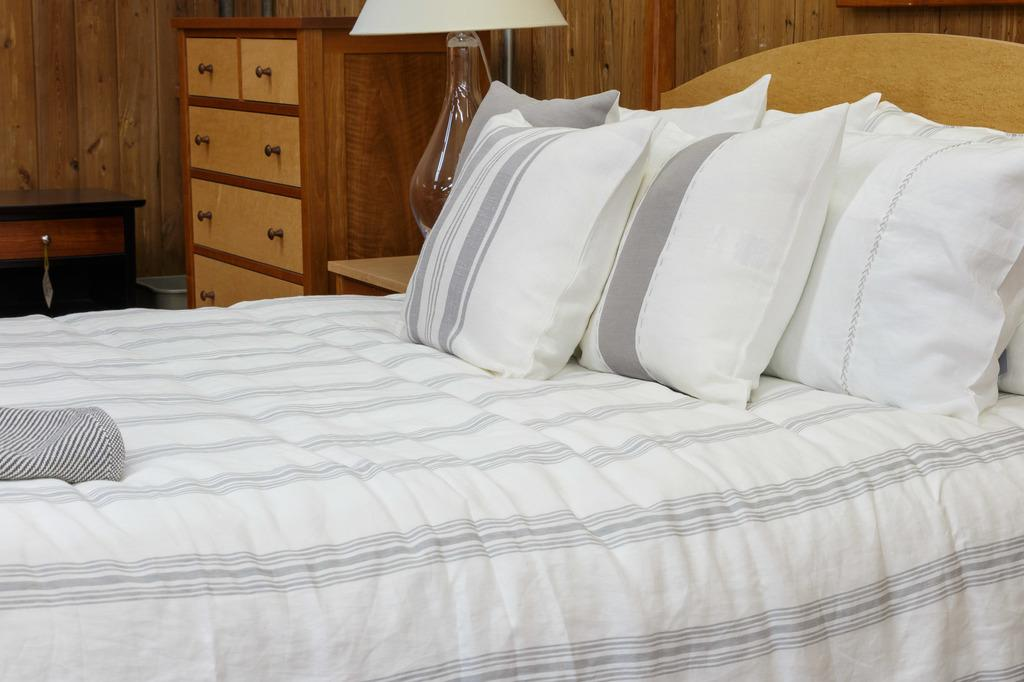What piece of furniture is the main subject in the image? There is a bed in the image. What is placed on the bed? There are many pillows on the bed. What is the color of the bed-sheet and pillow covers? The bed-sheet and pillow covers are white in color. What is the source of light in the image? There is a lamp in the image. What other piece of furniture can be seen in the image? There is a cupboard in the image. Can you tell me how many veins are visible on the bed in the image? There are no veins visible on the bed in the image; it is a piece of furniture covered with a bed-sheet and pillows. What type of women can be seen in the image? There are no women present in the image; it features a bed, pillows, a lamp, and a cupboard. 